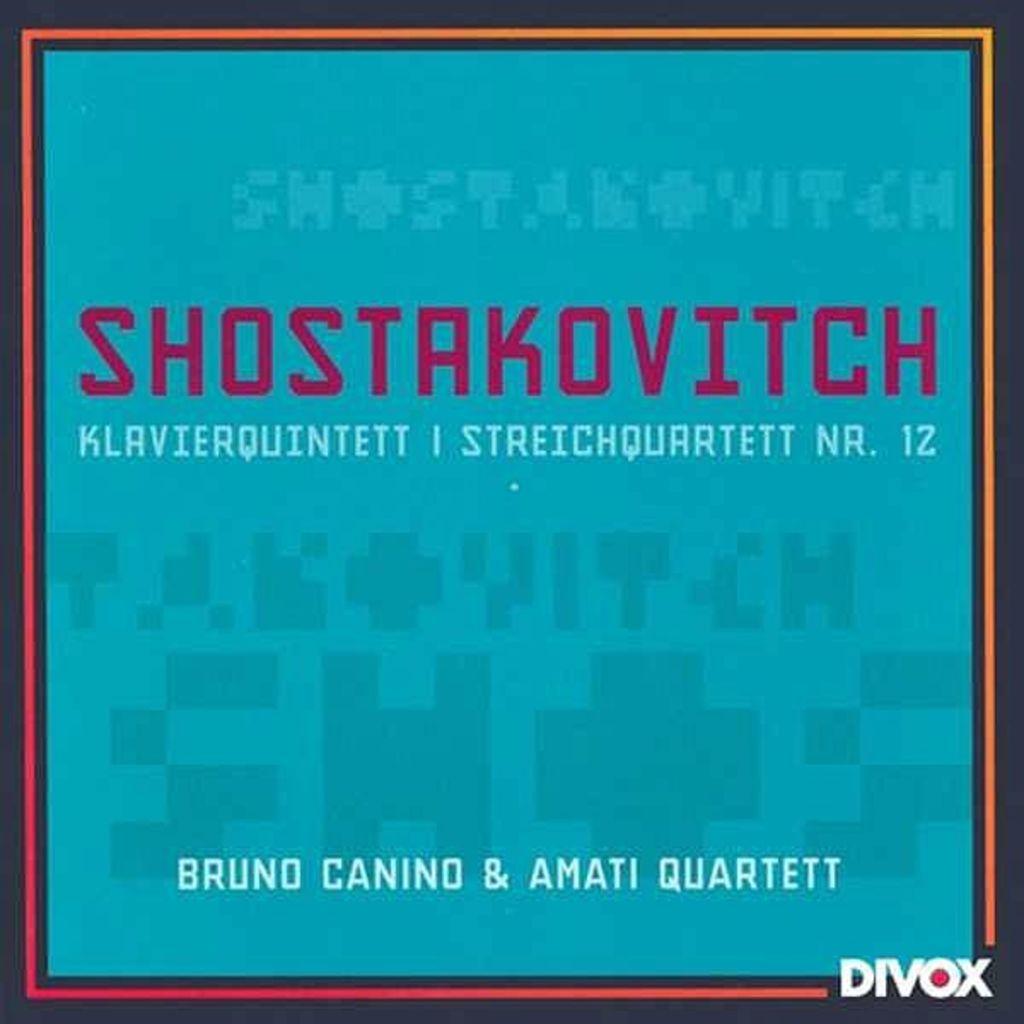What is the name on the left?
Your response must be concise. Bruno canino. What is the name following the &?
Give a very brief answer. Amati quartett. 